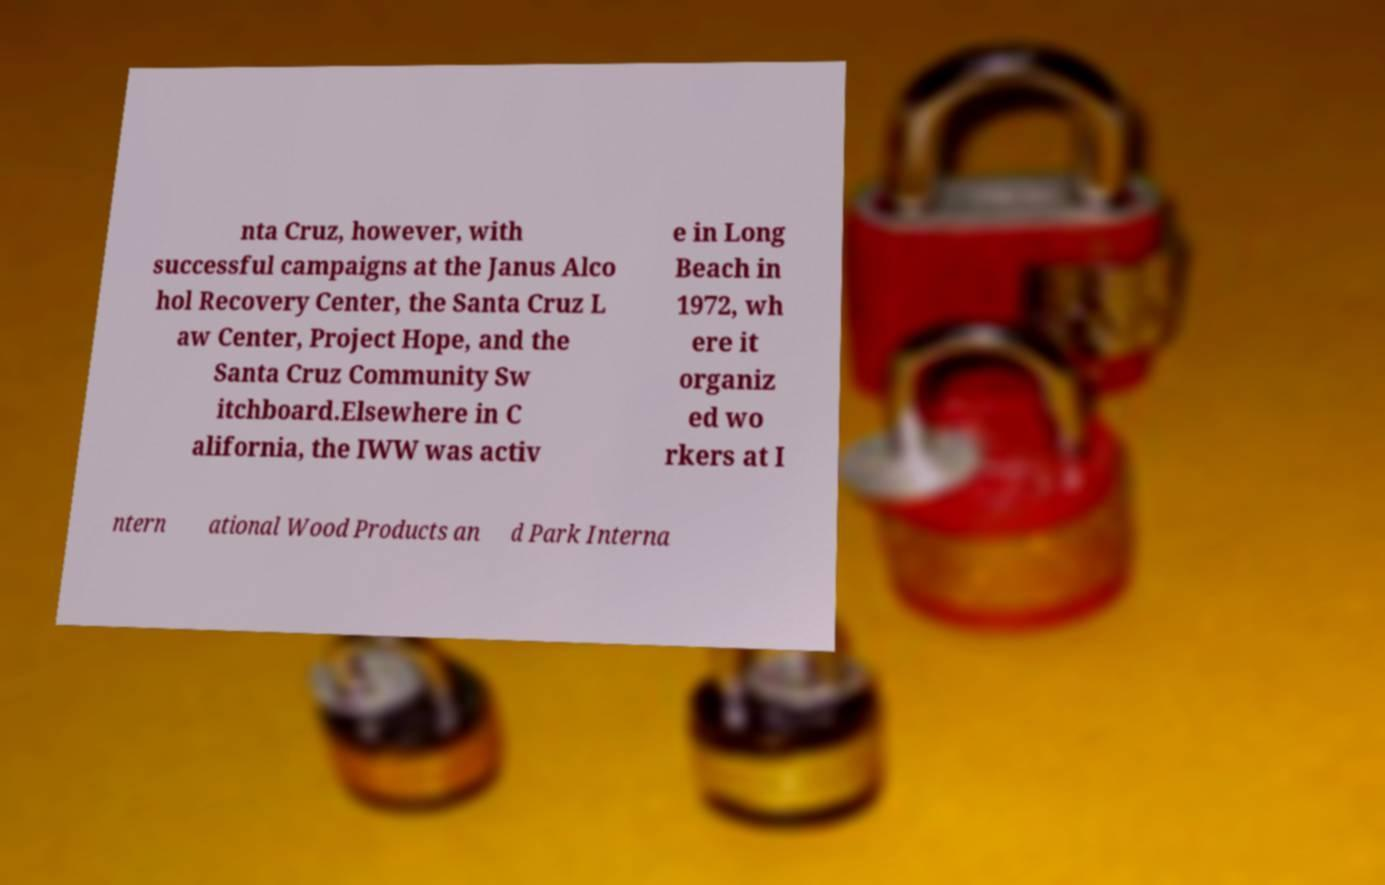Can you read and provide the text displayed in the image?This photo seems to have some interesting text. Can you extract and type it out for me? nta Cruz, however, with successful campaigns at the Janus Alco hol Recovery Center, the Santa Cruz L aw Center, Project Hope, and the Santa Cruz Community Sw itchboard.Elsewhere in C alifornia, the IWW was activ e in Long Beach in 1972, wh ere it organiz ed wo rkers at I ntern ational Wood Products an d Park Interna 